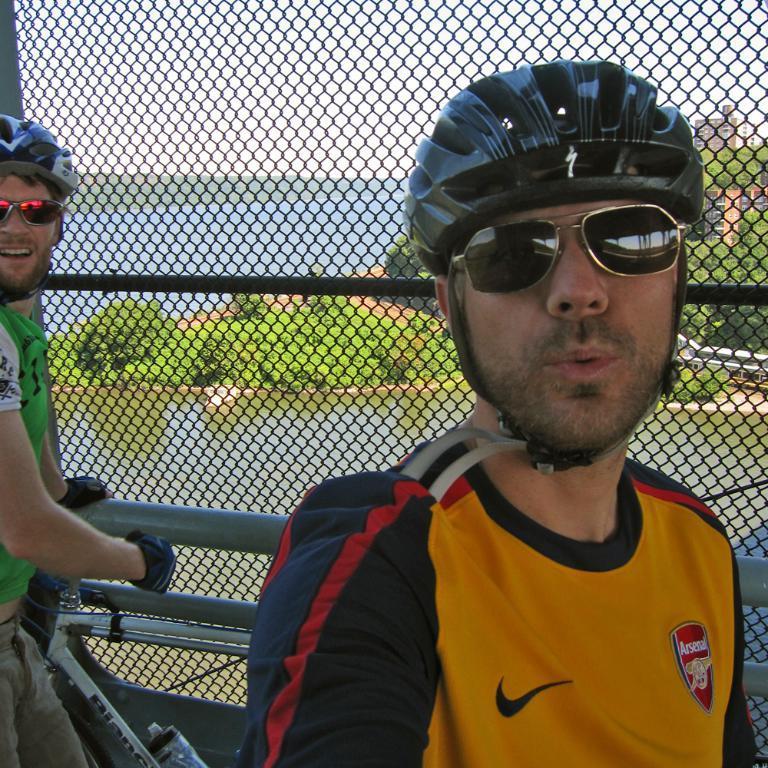Could you give a brief overview of what you see in this image? In this picture we can see there are two people with the goggles and helmets. A person is holding an iron rod. Behind the people there is the fence, a lake, trees, buildings and the sky. 